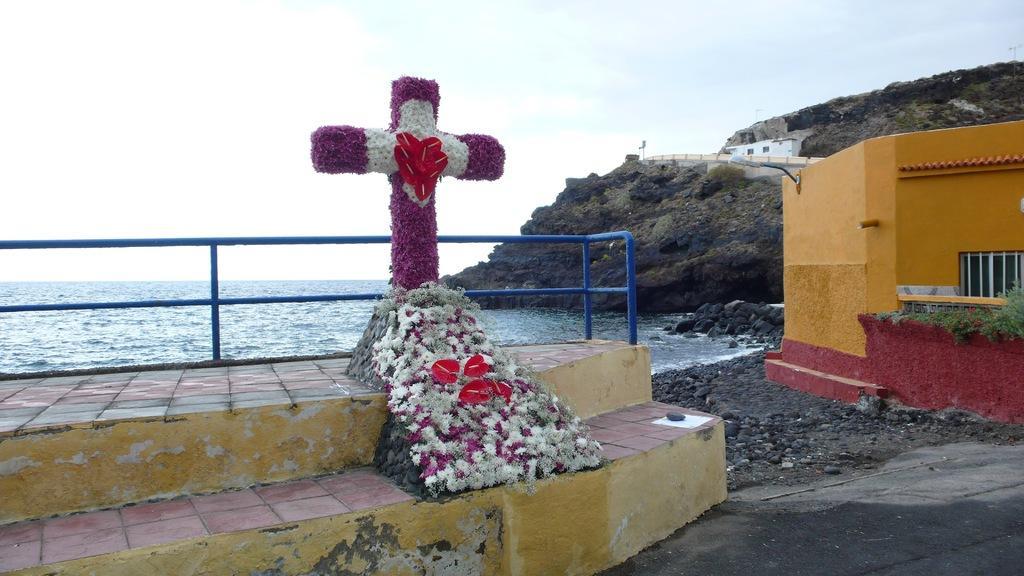Can you describe this image briefly? In this picture we can see flowers, cross on steps, fence, rocks, road, houses with windows, plants, water and in the background we can see the sky with clouds. 